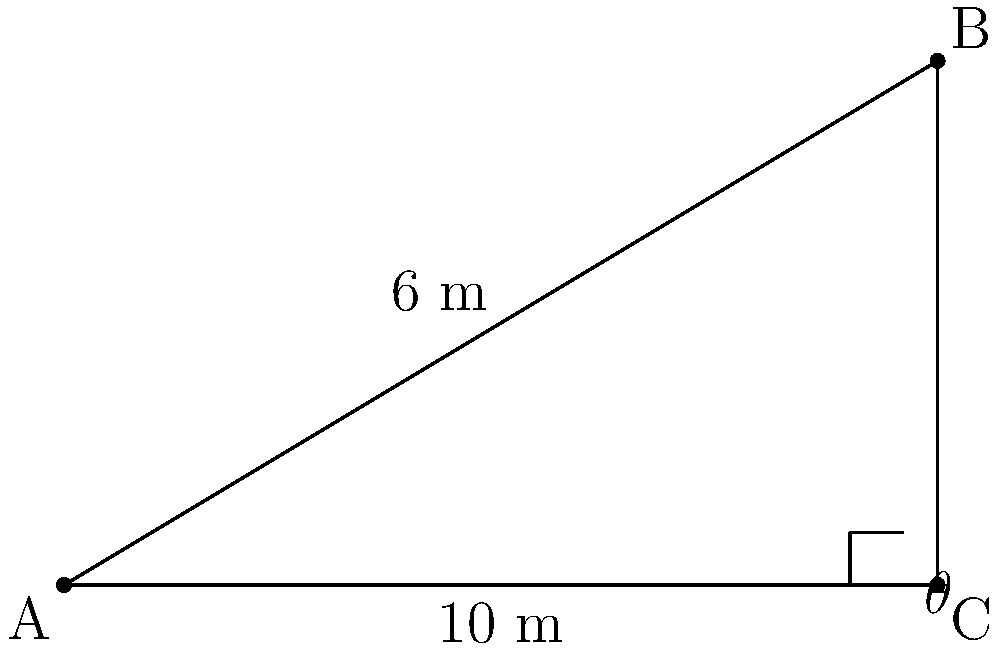At a crime scene, a bullet hole is found 6 meters above the ground on a wall. The distance from the wall to where the shooter likely stood is 10 meters. Using the principles of analytic geometry, calculate the angle of impact (θ) of the bullet. Round your answer to the nearest degree. To solve this problem, we'll use the concepts of slope and inverse tangent (arctangent) function. Let's approach this step-by-step:

1) First, we need to identify the rise and run of the trajectory:
   - Rise = 6 meters (vertical distance)
   - Run = 10 meters (horizontal distance)

2) The slope of the trajectory can be calculated using the formula:
   $$ \text{slope} = \frac{\text{rise}}{\text{run}} = \frac{6}{10} = 0.6 $$

3) The slope of a line is equal to the tangent of its angle with the horizontal. Therefore:
   $$ \tan(\theta) = 0.6 $$

4) To find θ, we need to use the inverse tangent (arctangent) function:
   $$ \theta = \tan^{-1}(0.6) $$

5) Using a calculator or trigonometric tables:
   $$ \theta \approx 30.96^\circ $$

6) Rounding to the nearest degree:
   $$ \theta \approx 31^\circ $$

Therefore, the angle of impact of the bullet is approximately 31 degrees.
Answer: 31° 